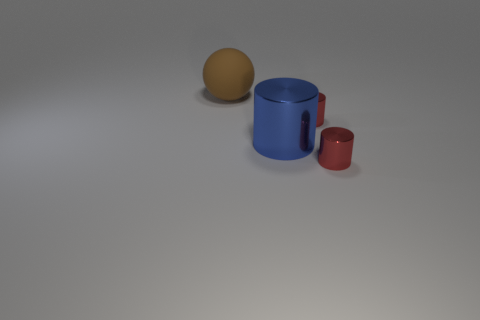What number of small things are either red cylinders or cylinders?
Keep it short and to the point. 2. There is a object that is both behind the large blue shiny thing and on the right side of the brown object; how big is it?
Provide a succinct answer. Small. There is a big blue cylinder; what number of blue objects are to the right of it?
Offer a very short reply. 0. How many cubes are red metallic things or large things?
Keep it short and to the point. 0. Is the number of brown balls to the left of the big brown rubber sphere less than the number of small red shiny objects?
Your answer should be very brief. Yes. What is the color of the object that is behind the blue metallic cylinder and in front of the matte object?
Your answer should be compact. Red. How many other things are the same shape as the matte thing?
Provide a short and direct response. 0. Is the number of big matte balls in front of the big brown thing less than the number of big brown objects that are in front of the blue cylinder?
Your answer should be compact. No. Does the large brown sphere have the same material as the large thing that is right of the matte ball?
Make the answer very short. No. Is there any other thing that has the same material as the big brown ball?
Your response must be concise. No. 